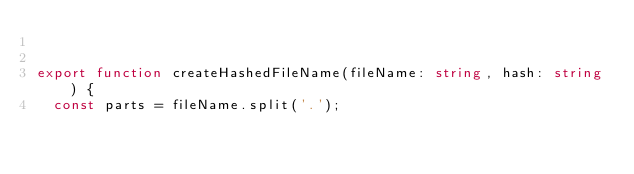Convert code to text. <code><loc_0><loc_0><loc_500><loc_500><_TypeScript_>

export function createHashedFileName(fileName: string, hash: string) {
  const parts = fileName.split('.');</code> 